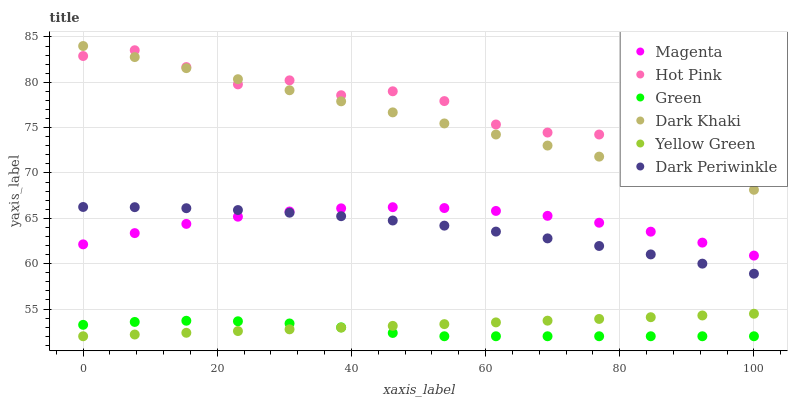Does Green have the minimum area under the curve?
Answer yes or no. Yes. Does Hot Pink have the maximum area under the curve?
Answer yes or no. Yes. Does Dark Khaki have the minimum area under the curve?
Answer yes or no. No. Does Dark Khaki have the maximum area under the curve?
Answer yes or no. No. Is Yellow Green the smoothest?
Answer yes or no. Yes. Is Hot Pink the roughest?
Answer yes or no. Yes. Is Dark Khaki the smoothest?
Answer yes or no. No. Is Dark Khaki the roughest?
Answer yes or no. No. Does Yellow Green have the lowest value?
Answer yes or no. Yes. Does Dark Khaki have the lowest value?
Answer yes or no. No. Does Dark Khaki have the highest value?
Answer yes or no. Yes. Does Hot Pink have the highest value?
Answer yes or no. No. Is Yellow Green less than Dark Periwinkle?
Answer yes or no. Yes. Is Dark Khaki greater than Yellow Green?
Answer yes or no. Yes. Does Yellow Green intersect Green?
Answer yes or no. Yes. Is Yellow Green less than Green?
Answer yes or no. No. Is Yellow Green greater than Green?
Answer yes or no. No. Does Yellow Green intersect Dark Periwinkle?
Answer yes or no. No. 